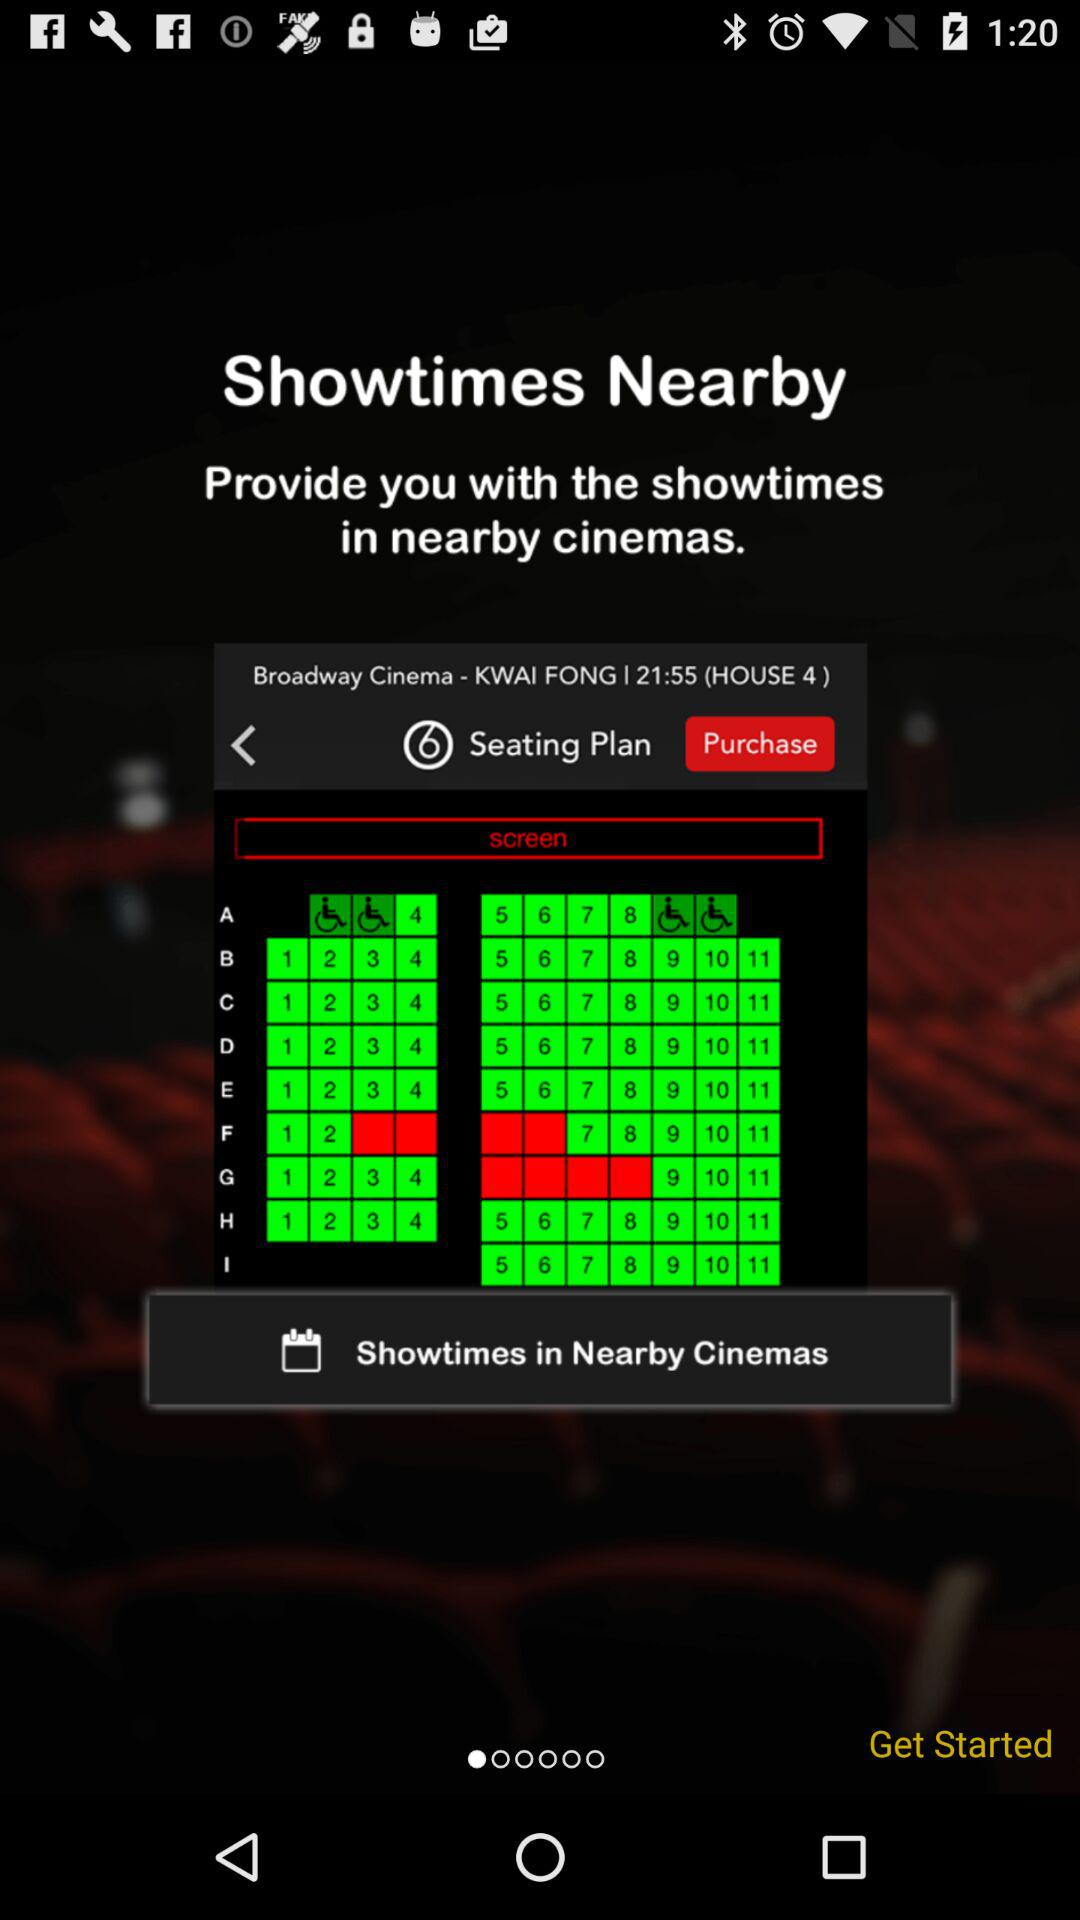What is the mentioned location? The mentioned location is the "KWAI FONG". 